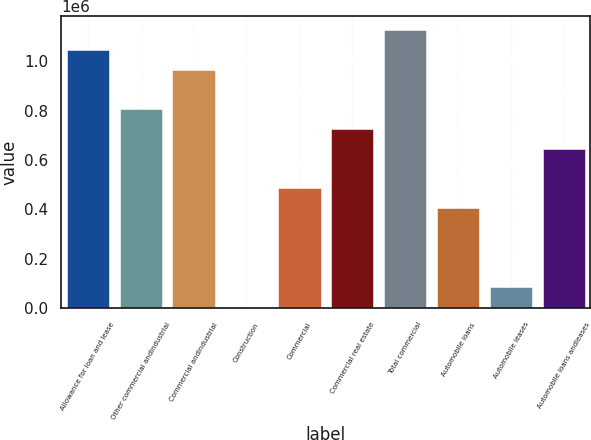Convert chart to OTSL. <chart><loc_0><loc_0><loc_500><loc_500><bar_chart><fcel>Allowance for loan and lease<fcel>Other commercial andindustrial<fcel>Commercial andindustrial<fcel>Construction<fcel>Commercial<fcel>Commercial real estate<fcel>Total commercial<fcel>Automobile loans<fcel>Automobile leases<fcel>Automobile loans andleases<nl><fcel>1.04624e+06<fcel>806330<fcel>966270<fcel>6631<fcel>486450<fcel>726360<fcel>1.12621e+06<fcel>406480<fcel>86600.9<fcel>646390<nl></chart> 